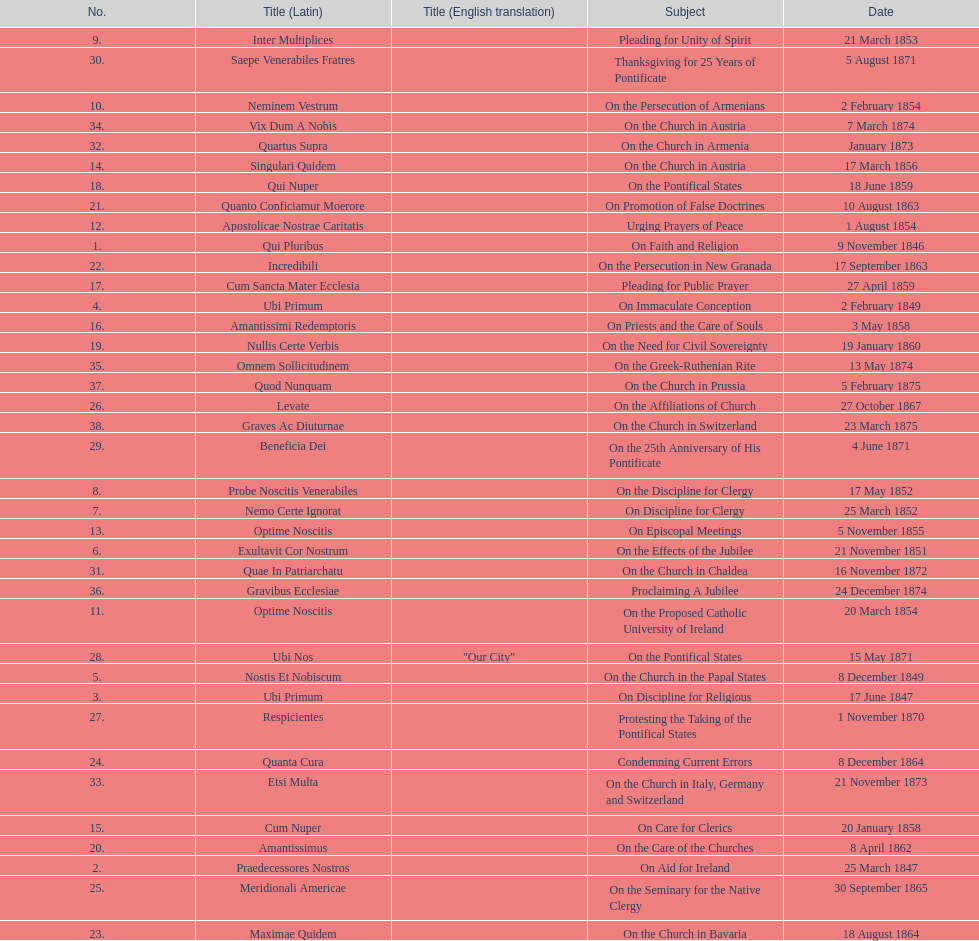What is the total number of title? 38. 